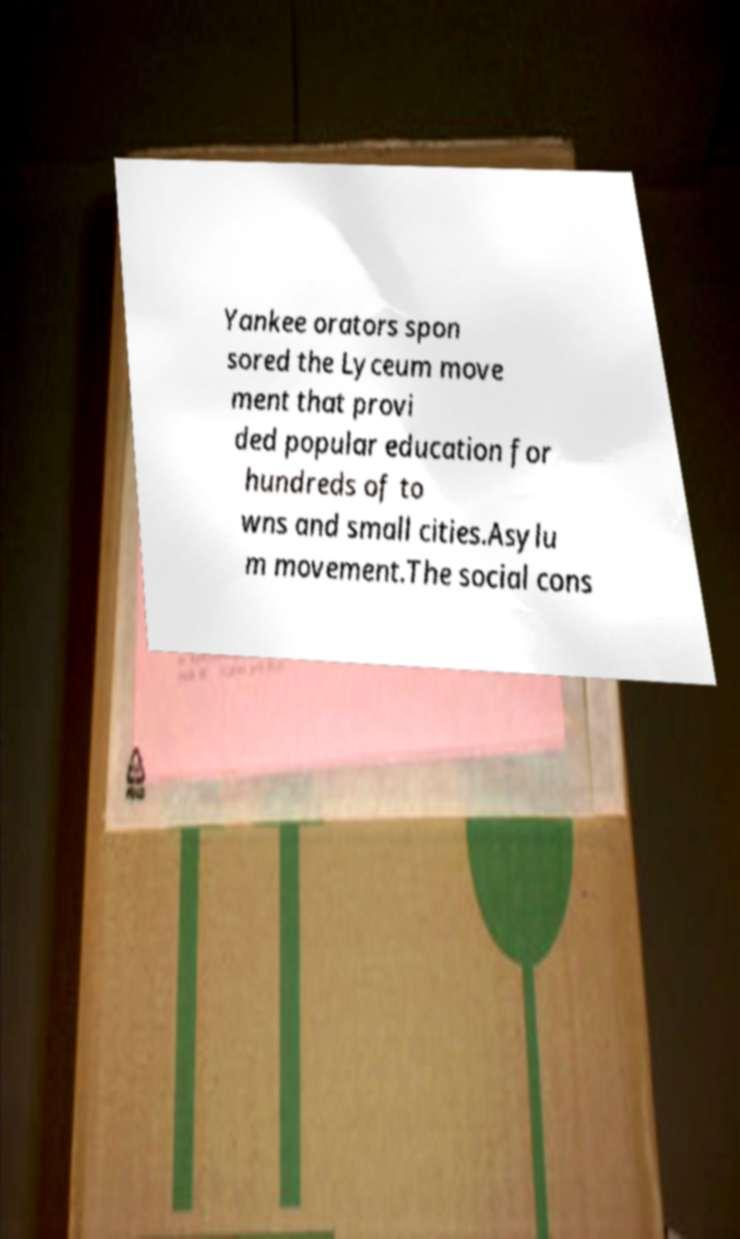Please read and relay the text visible in this image. What does it say? Yankee orators spon sored the Lyceum move ment that provi ded popular education for hundreds of to wns and small cities.Asylu m movement.The social cons 